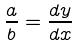<formula> <loc_0><loc_0><loc_500><loc_500>\frac { a } { b } = \frac { d y } { d x }</formula> 